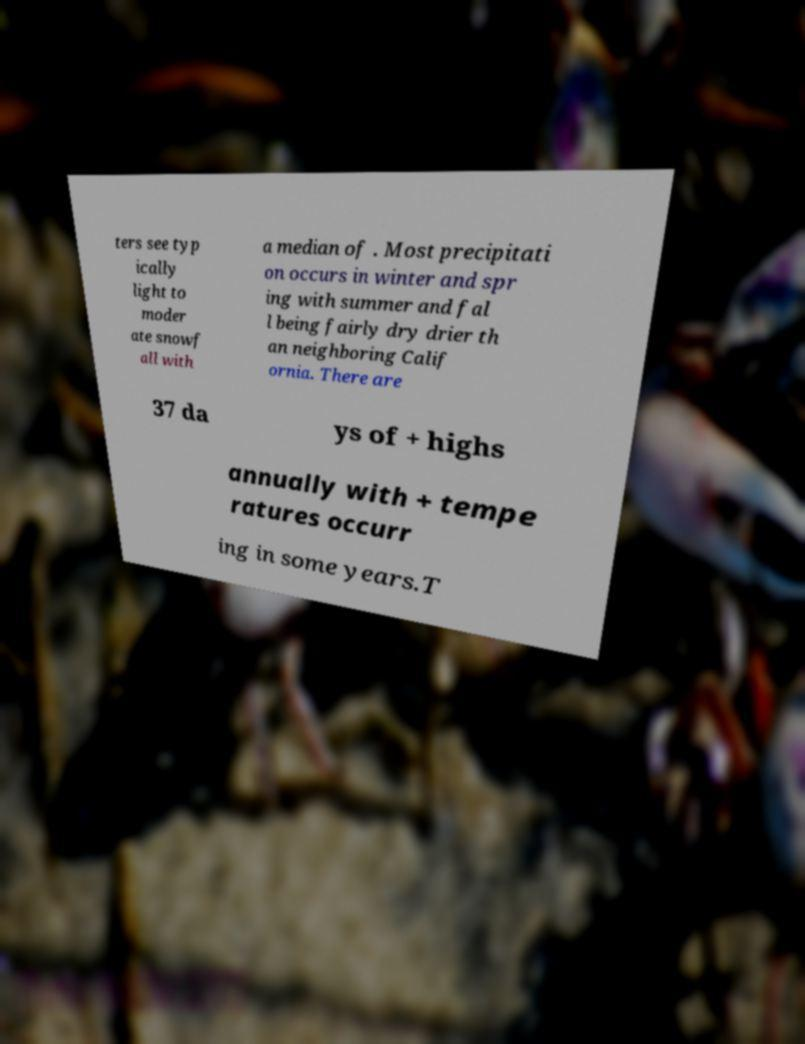Please identify and transcribe the text found in this image. ters see typ ically light to moder ate snowf all with a median of . Most precipitati on occurs in winter and spr ing with summer and fal l being fairly dry drier th an neighboring Calif ornia. There are 37 da ys of + highs annually with + tempe ratures occurr ing in some years.T 